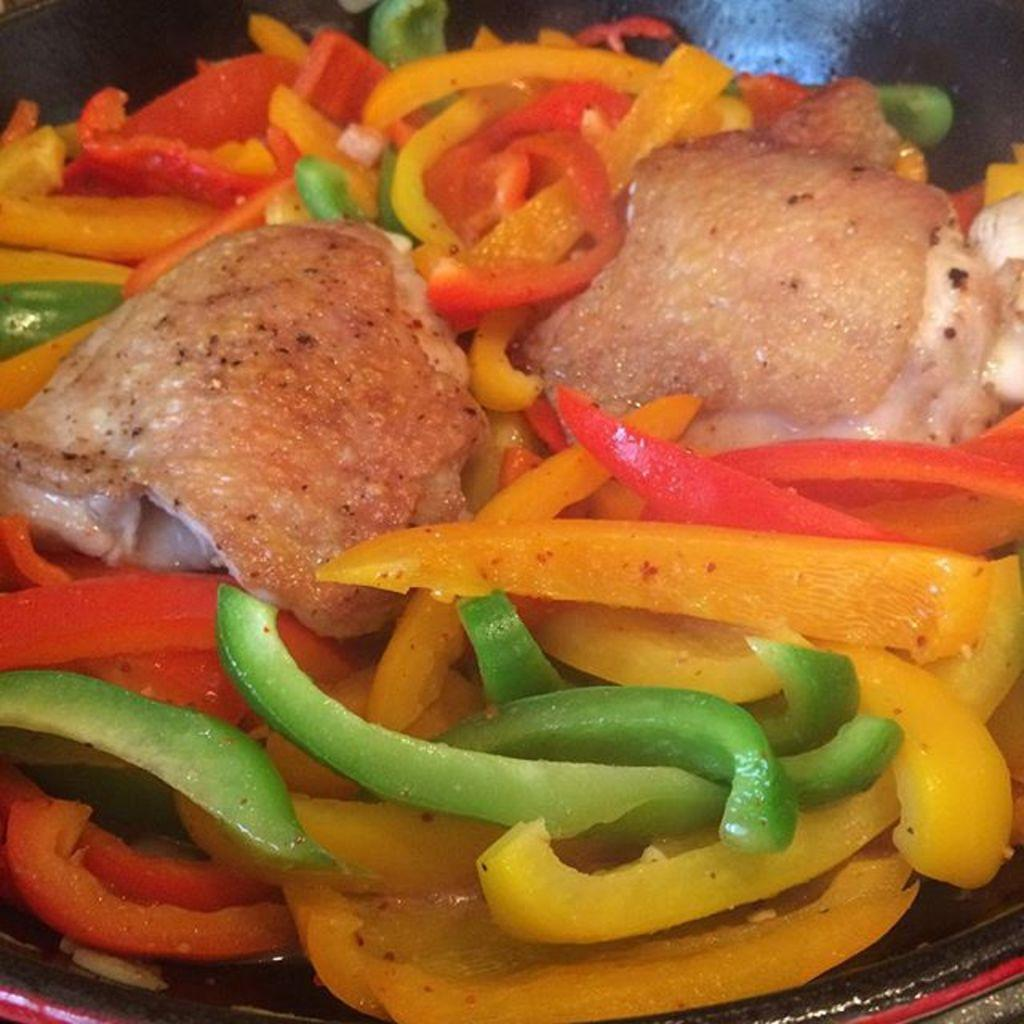What is the main subject of the image? The main subject of the image is food. Where is the food located in the image? The food is in the center of the image. What is the manager's rate of quartz production in the image? There is no manager or quartz production present in the image; it features food in the center. 